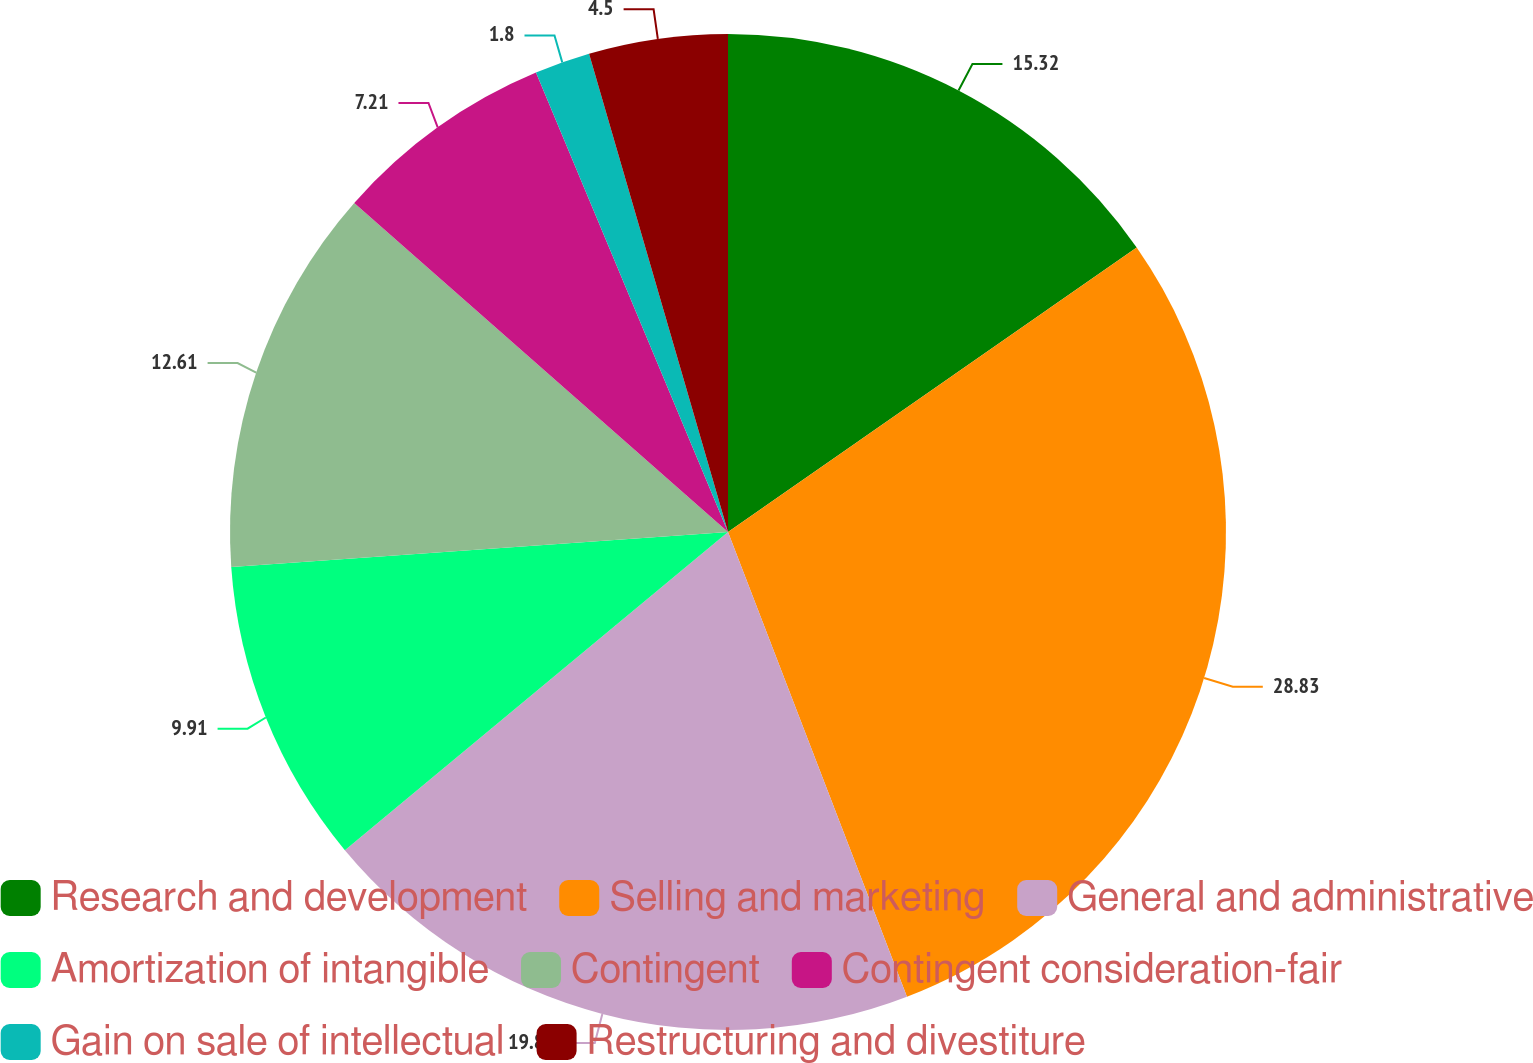Convert chart. <chart><loc_0><loc_0><loc_500><loc_500><pie_chart><fcel>Research and development<fcel>Selling and marketing<fcel>General and administrative<fcel>Amortization of intangible<fcel>Contingent<fcel>Contingent consideration-fair<fcel>Gain on sale of intellectual<fcel>Restructuring and divestiture<nl><fcel>15.32%<fcel>28.83%<fcel>19.82%<fcel>9.91%<fcel>12.61%<fcel>7.21%<fcel>1.8%<fcel>4.5%<nl></chart> 